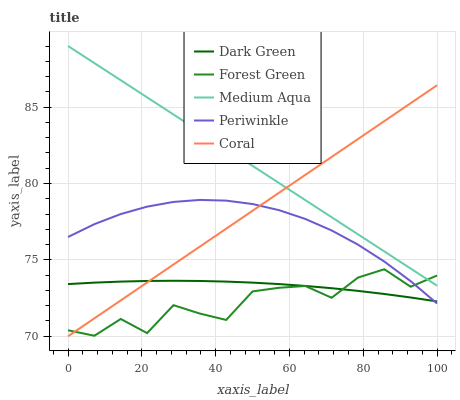Does Forest Green have the minimum area under the curve?
Answer yes or no. Yes. Does Medium Aqua have the maximum area under the curve?
Answer yes or no. Yes. Does Medium Aqua have the minimum area under the curve?
Answer yes or no. No. Does Forest Green have the maximum area under the curve?
Answer yes or no. No. Is Medium Aqua the smoothest?
Answer yes or no. Yes. Is Forest Green the roughest?
Answer yes or no. Yes. Is Forest Green the smoothest?
Answer yes or no. No. Is Medium Aqua the roughest?
Answer yes or no. No. Does Coral have the lowest value?
Answer yes or no. Yes. Does Forest Green have the lowest value?
Answer yes or no. No. Does Medium Aqua have the highest value?
Answer yes or no. Yes. Does Forest Green have the highest value?
Answer yes or no. No. Is Periwinkle less than Medium Aqua?
Answer yes or no. Yes. Is Medium Aqua greater than Periwinkle?
Answer yes or no. Yes. Does Dark Green intersect Coral?
Answer yes or no. Yes. Is Dark Green less than Coral?
Answer yes or no. No. Is Dark Green greater than Coral?
Answer yes or no. No. Does Periwinkle intersect Medium Aqua?
Answer yes or no. No. 